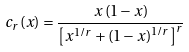Convert formula to latex. <formula><loc_0><loc_0><loc_500><loc_500>c _ { r } ( x ) & = \frac { x \left ( 1 - x \right ) } { \left [ x ^ { 1 / r } + \left ( 1 - x \right ) ^ { 1 / r } \right ] ^ { r } } \,</formula> 